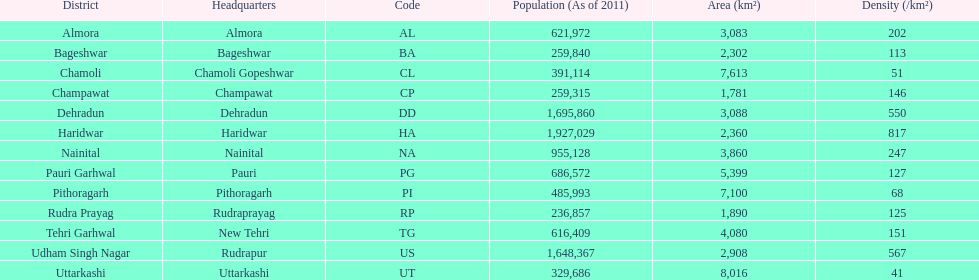What is the next most populous district after haridwar? Dehradun. 